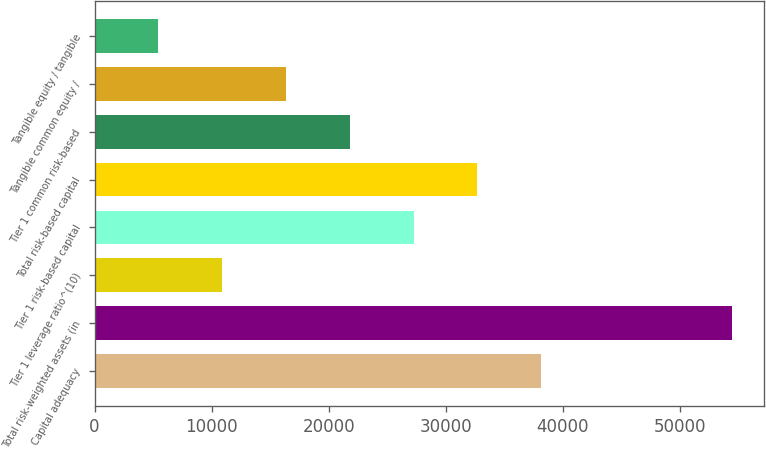Convert chart. <chart><loc_0><loc_0><loc_500><loc_500><bar_chart><fcel>Capital adequacy<fcel>Total risk-weighted assets (in<fcel>Tier 1 leverage ratio^(10)<fcel>Tier 1 risk-based capital<fcel>Total risk-based capital<fcel>Tier 1 common risk-based<fcel>Tangible common equity /<fcel>Tangible equity / tangible<nl><fcel>38137.7<fcel>54479<fcel>10902.3<fcel>27243.6<fcel>32690.7<fcel>21796.5<fcel>16349.4<fcel>5455.25<nl></chart> 